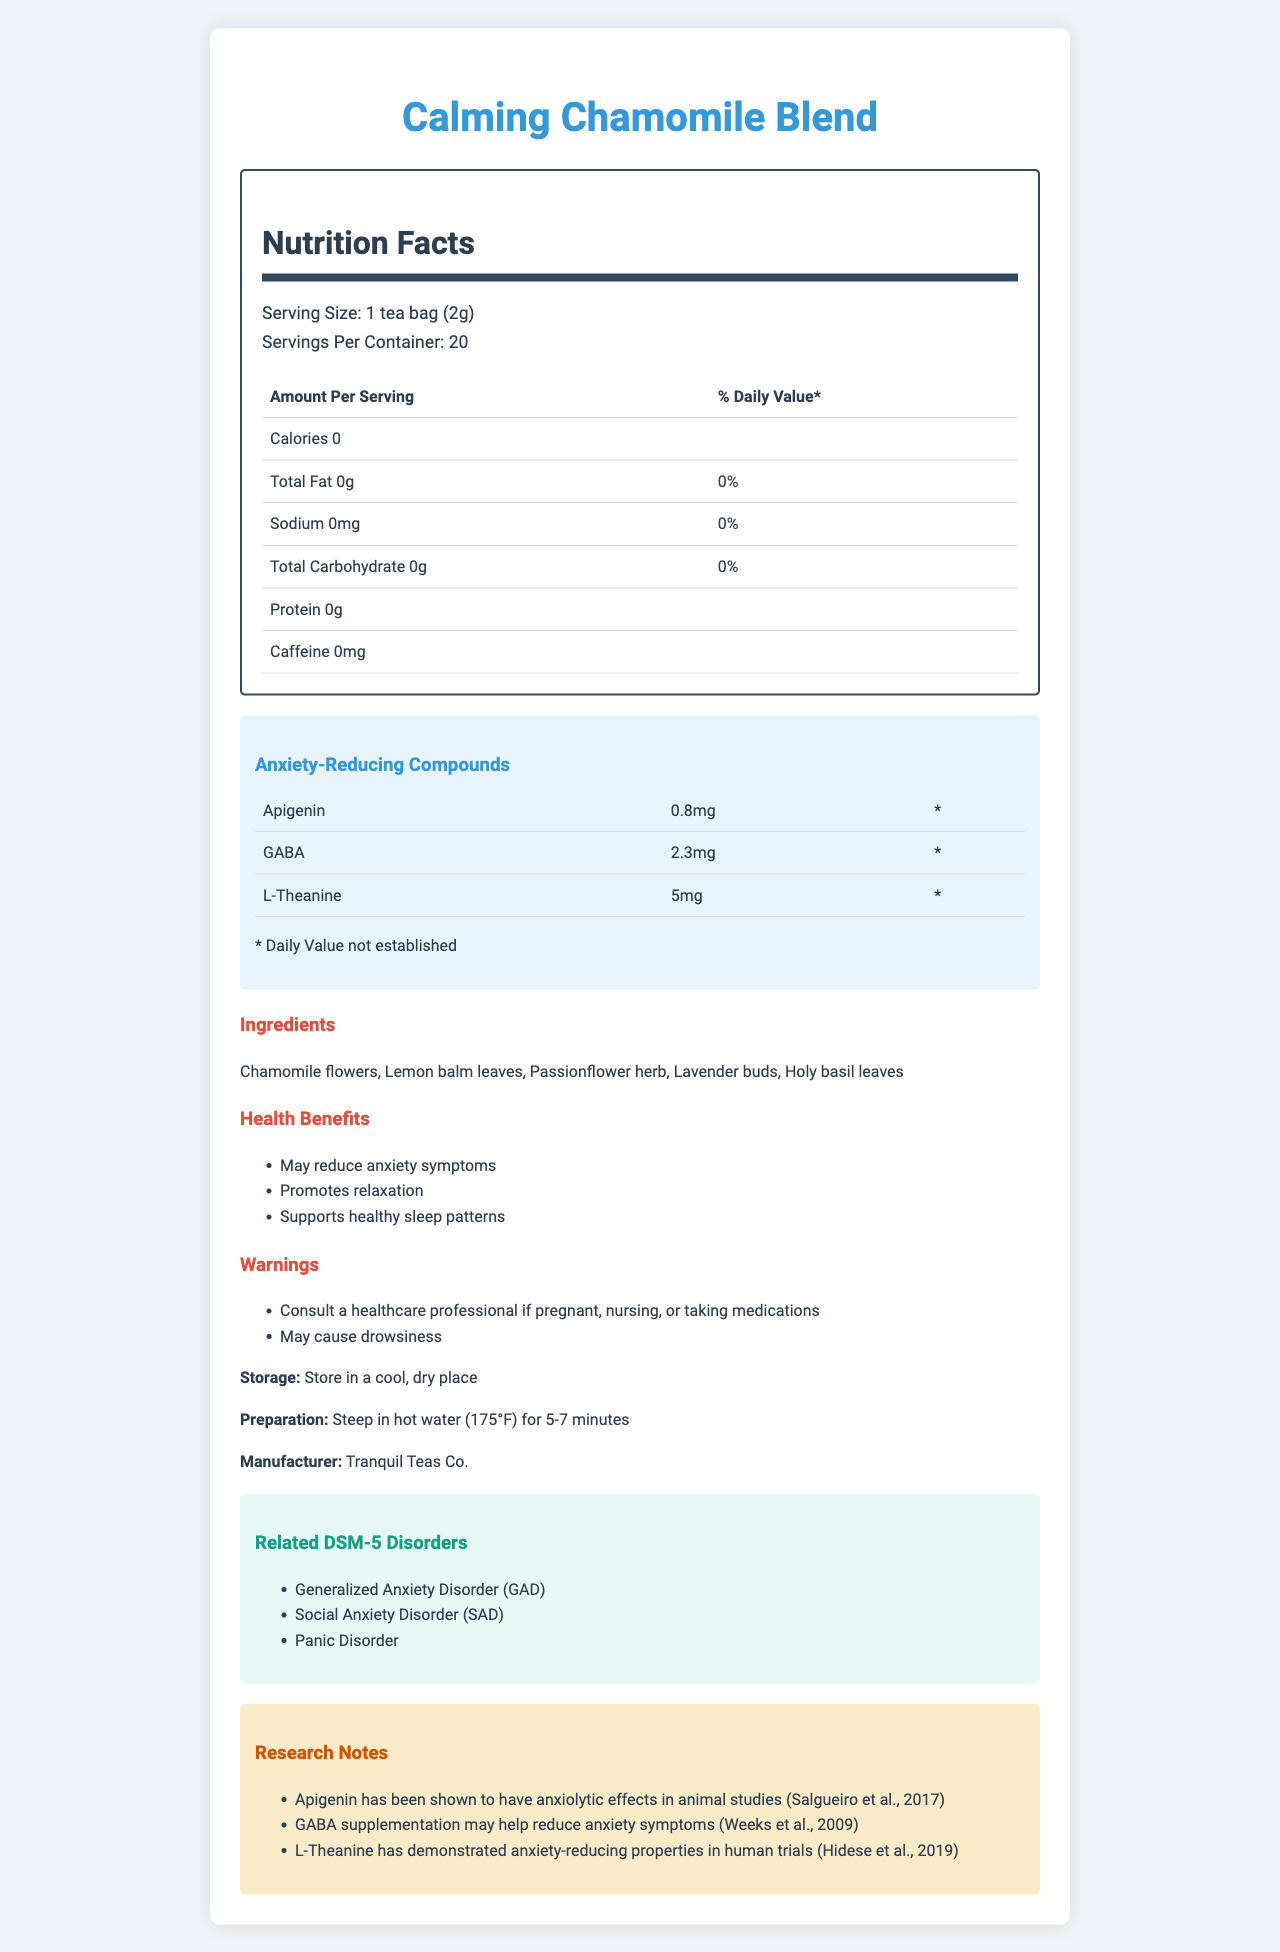what is the serving size for the Calming Chamomile Blend? The document clearly states that the serving size is 1 tea bag (2g).
Answer: 1 tea bag (2g) how many servings are there per container? According to the document, there are 20 servings per container.
Answer: 20 how many calories are in one serving of this herbal tea? The nutrition facts indicate that each serving contains 0 calories.
Answer: 0 name one of the anxiety-reducing compounds found in the Calming Chamomile Blend? The document lists Apigenin as one of the anxiety-reducing compounds found in the blend.
Answer: Apigenin what is the amount of GABA in one serving of the tea? The document specifies that there is 2.3mg of GABA per serving.
Answer: 2.3mg what are the ingredients in the Calming Chamomile Blend? The document lists these five ingredients.
Answer: Chamomile flowers, Lemon balm leaves, Passionflower herb, Lavender buds, Holy basil leaves what are the health benefits of this herbal tea? The document mentions these three health benefits.
Answer: May reduce anxiety symptoms, Promotes relaxation, Supports healthy sleep patterns how should the tea be stored? The document advises storing the tea in a cool, dry place.
Answer: Store in a cool, dry place which compound has the highest amount per serving? L-Theanine is listed with the highest amount of 5mg per serving.
Answer: L-Theanine (5mg) consulting a healthcare professional is recommended under which circumstances? The document recommends consulting a healthcare professional if pregnant, nursing, or taking medications.
Answer: When pregnant, nursing, or taking medications which disorder is not listed as related to the DSM-5 disorders in the document? A. Generalized Anxiety Disorder B. Social Anxiety Disorder C. Panic Disorder D. Obsessive-Compulsive Disorder Obsessive-Compulsive Disorder is not listed among the related DSM-5 disorders in the document.
Answer: D which ingredient is part of the Calming Chamomile Blend? A. Green tea B. Chamomile flowers C. Peppermint leaves The document lists Chamomile flowers as an ingredient, not Green tea or Peppermint leaves.
Answer: B does the Calming Chamomile Blend contain caffeine? According to the document, the tea has 0mg of caffeine.
Answer: No what is the manufacturer of the Calming Chamomile Blend? The document states that the manufacturer is Tranquil Teas Co.
Answer: Tranquil Teas Co. is there a statement about the daily value of the anxiety-reducing compounds? The document contains a statement that the daily value is not established for these compounds.
Answer: Yes summarize the document. The document is a comprehensive product summary that includes nutrition facts, ingredients, health benefits, warnings, storage instructions, and connections to DSM-5 anxiety-related disorders along with relevant research notes.
Answer: The document details the Nutrition Facts for the "Calming Chamomile Blend" herbal tea, listing its serving size, nutrient content, and anxiety-reducing compounds like Apigenin, GABA, and L-Theanine. It provides information on ingredients, health benefits, storage, preparation, manufacturer, related DSM-5 disorders, and research notes. how does GABA supplementation affect anxiety? The document mentions that GABA supplementation may help reduce anxiety symptoms, but it does not provide detailed effects or mechanisms.
Answer: Not enough information 